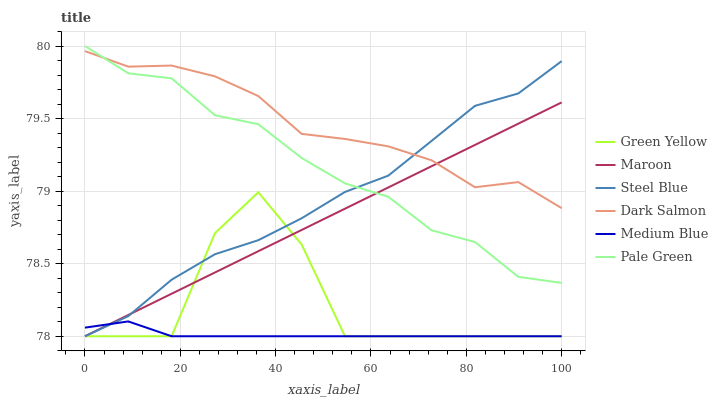Does Steel Blue have the minimum area under the curve?
Answer yes or no. No. Does Steel Blue have the maximum area under the curve?
Answer yes or no. No. Is Steel Blue the smoothest?
Answer yes or no. No. Is Steel Blue the roughest?
Answer yes or no. No. Does Dark Salmon have the lowest value?
Answer yes or no. No. Does Steel Blue have the highest value?
Answer yes or no. No. Is Green Yellow less than Pale Green?
Answer yes or no. Yes. Is Dark Salmon greater than Medium Blue?
Answer yes or no. Yes. Does Green Yellow intersect Pale Green?
Answer yes or no. No. 